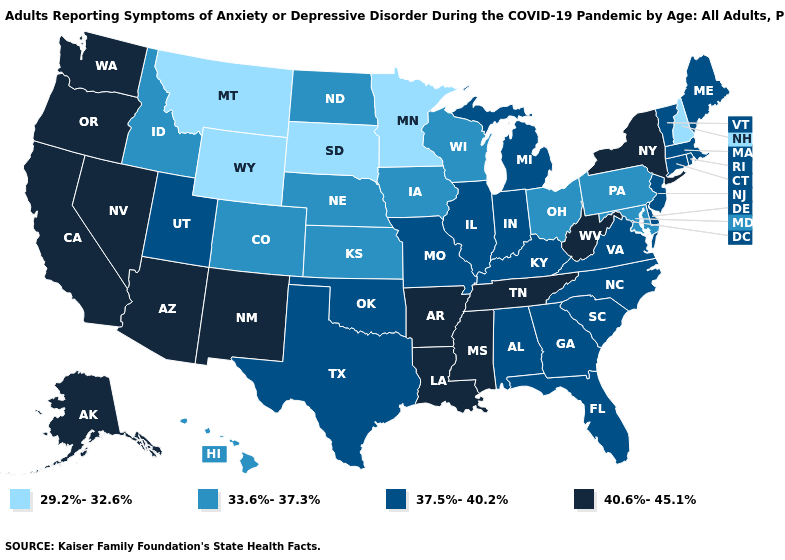Which states have the highest value in the USA?
Be succinct. Alaska, Arizona, Arkansas, California, Louisiana, Mississippi, Nevada, New Mexico, New York, Oregon, Tennessee, Washington, West Virginia. What is the value of Vermont?
Give a very brief answer. 37.5%-40.2%. Does Minnesota have the highest value in the MidWest?
Give a very brief answer. No. Among the states that border Nevada , does Arizona have the lowest value?
Answer briefly. No. What is the highest value in the Northeast ?
Be succinct. 40.6%-45.1%. Is the legend a continuous bar?
Answer briefly. No. Name the states that have a value in the range 33.6%-37.3%?
Answer briefly. Colorado, Hawaii, Idaho, Iowa, Kansas, Maryland, Nebraska, North Dakota, Ohio, Pennsylvania, Wisconsin. Name the states that have a value in the range 29.2%-32.6%?
Write a very short answer. Minnesota, Montana, New Hampshire, South Dakota, Wyoming. What is the highest value in the USA?
Answer briefly. 40.6%-45.1%. Among the states that border North Carolina , which have the highest value?
Be succinct. Tennessee. What is the value of Mississippi?
Give a very brief answer. 40.6%-45.1%. Does Nevada have the lowest value in the USA?
Answer briefly. No. What is the value of Illinois?
Keep it brief. 37.5%-40.2%. What is the value of South Dakota?
Quick response, please. 29.2%-32.6%. What is the value of Delaware?
Be succinct. 37.5%-40.2%. 